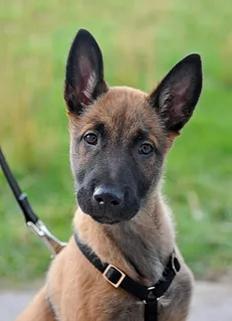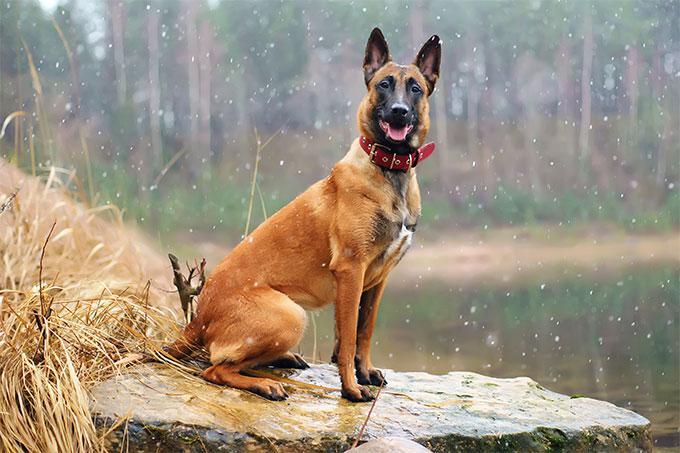The first image is the image on the left, the second image is the image on the right. Examine the images to the left and right. Is the description "An image shows a young dog wearing a black harness with a leash attached." accurate? Answer yes or no. Yes. The first image is the image on the left, the second image is the image on the right. Evaluate the accuracy of this statement regarding the images: "In one of the images there is a dog sitting and wear a harness with a leash attached.". Is it true? Answer yes or no. Yes. 